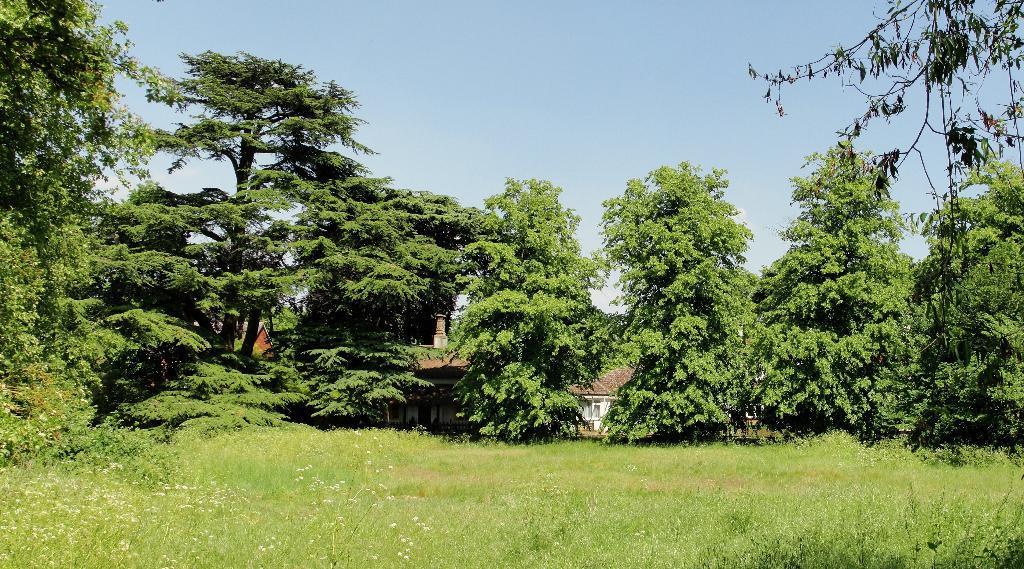Please provide a concise description of this image. In this picture there is grassland at the bottom side of the image and there are trees in the center of the image and there are houses in the background area of the image. 